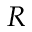<formula> <loc_0><loc_0><loc_500><loc_500>R</formula> 